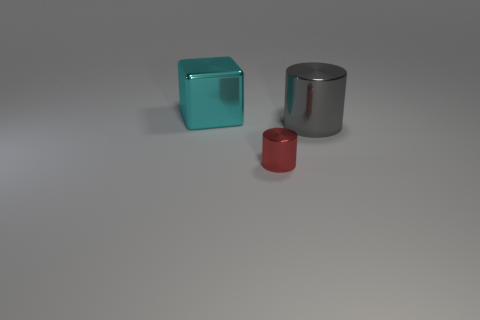Add 3 big purple shiny spheres. How many objects exist? 6 Subtract all cylinders. How many objects are left? 1 Add 1 large cyan things. How many large cyan things are left? 2 Add 3 blue metal cubes. How many blue metal cubes exist? 3 Subtract 0 brown cubes. How many objects are left? 3 Subtract all metallic cylinders. Subtract all big cyan shiny blocks. How many objects are left? 0 